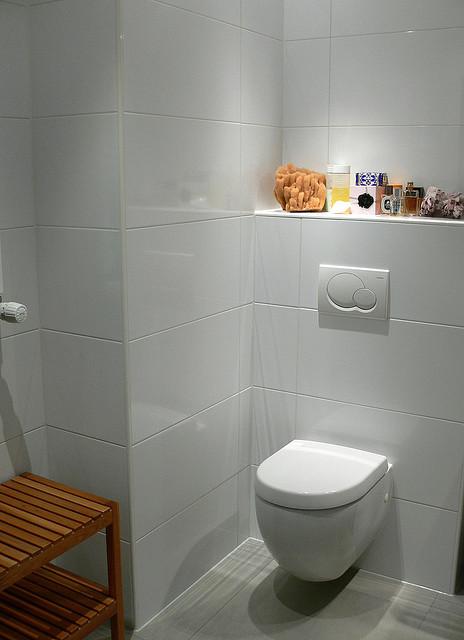Is the toilet being used?
Write a very short answer. No. Where is the light shining?
Concise answer only. On toilet. What room is the picture taken in?
Be succinct. Bathroom. 